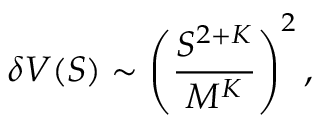Convert formula to latex. <formula><loc_0><loc_0><loc_500><loc_500>\delta V ( S ) \sim \left ( \frac { S ^ { 2 + K } } { M ^ { K } } \right ) ^ { 2 } ,</formula> 